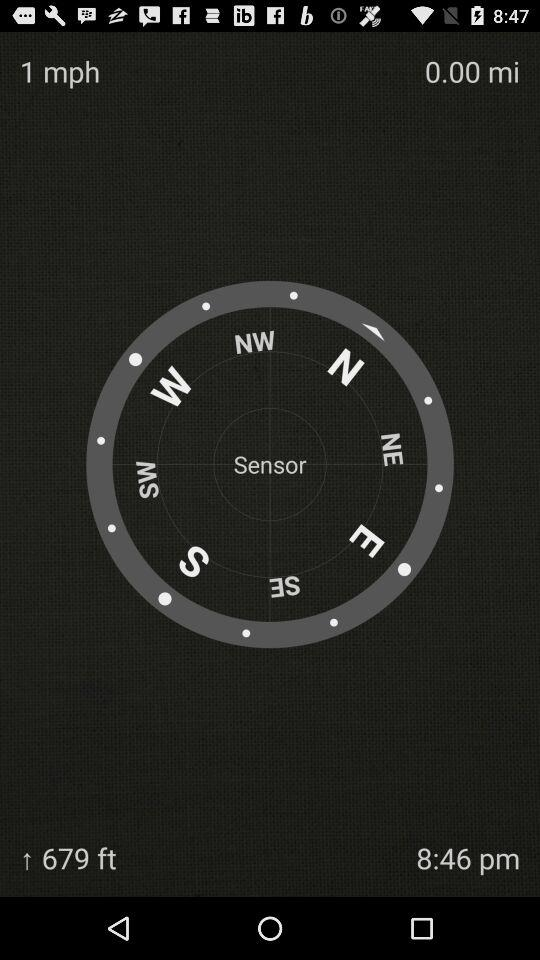How many feet higher is the user than sea level?
Answer the question using a single word or phrase. 679 